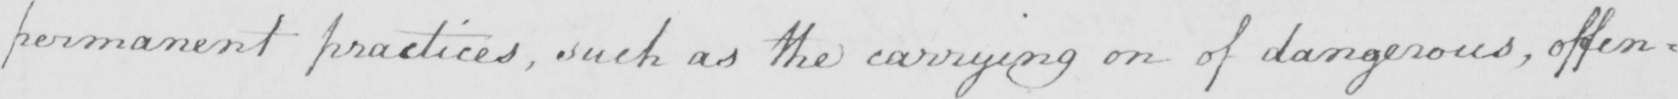What text is written in this handwritten line? permanent practices, such as the carrying on of dangerous, offen= 